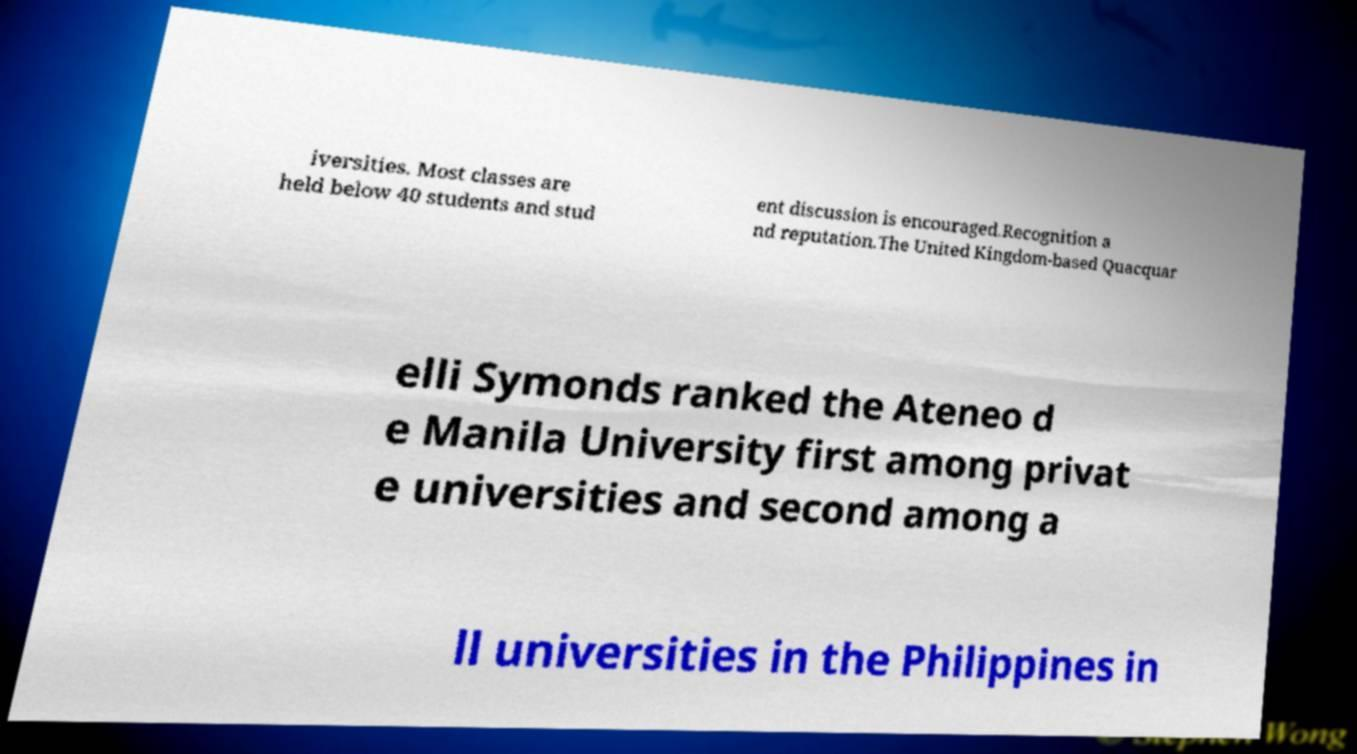Please read and relay the text visible in this image. What does it say? iversities. Most classes are held below 40 students and stud ent discussion is encouraged.Recognition a nd reputation.The United Kingdom-based Quacquar elli Symonds ranked the Ateneo d e Manila University first among privat e universities and second among a ll universities in the Philippines in 